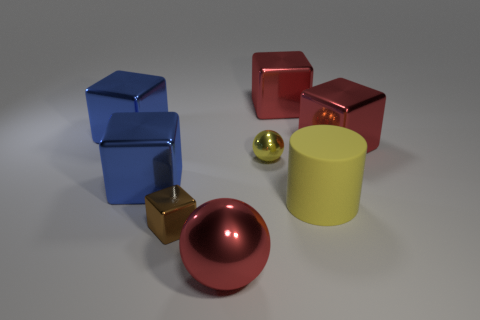Are there the same number of balls that are behind the brown thing and tiny metal spheres?
Make the answer very short. Yes. Are there any other tiny green objects that have the same shape as the matte object?
Keep it short and to the point. No. There is a object that is left of the tiny yellow shiny thing and behind the small yellow object; what shape is it?
Provide a succinct answer. Cube. Are the small yellow sphere and the tiny object in front of the matte thing made of the same material?
Offer a terse response. Yes. There is a yellow cylinder; are there any shiny cubes in front of it?
Ensure brevity in your answer.  Yes. How many things are either big objects or shiny things that are in front of the small yellow metal sphere?
Your response must be concise. 7. There is a sphere that is in front of the shiny sphere to the right of the large sphere; what is its color?
Offer a very short reply. Red. What number of other things are the same material as the small brown thing?
Provide a succinct answer. 6. How many metal objects are either big yellow objects or red blocks?
Offer a terse response. 2. What is the color of the other metal thing that is the same shape as the small yellow metal thing?
Offer a very short reply. Red. 